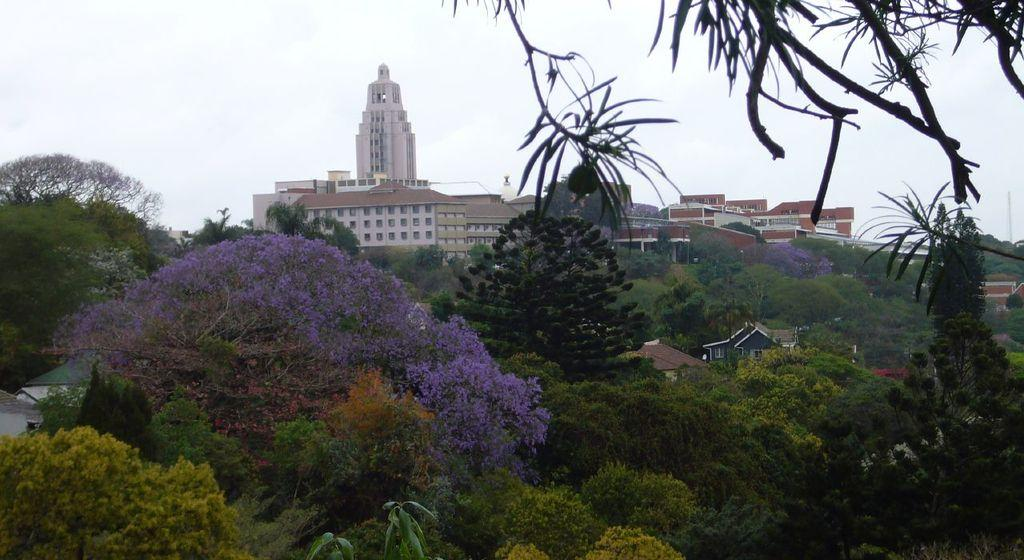What type of natural elements can be seen in the image? There are trees in the image. What type of structures are present in the image? There are buildings with windows in the image. What is visible in the background of the image? The sky is visible in the background of the image. What type of feast is being prepared in the image? There is no indication of a feast or any food preparation in the image. What type of root can be seen growing near the trees in the image? There is no root visible in the image; only trees and buildings are present. 